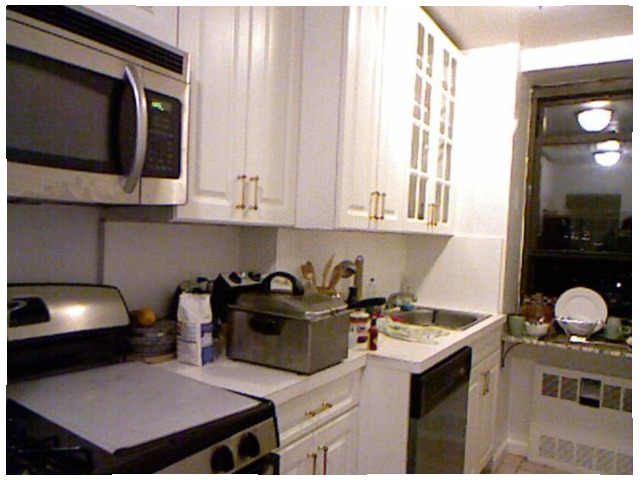<image>
Is there a stove under the microwave? Yes. The stove is positioned underneath the microwave, with the microwave above it in the vertical space. 